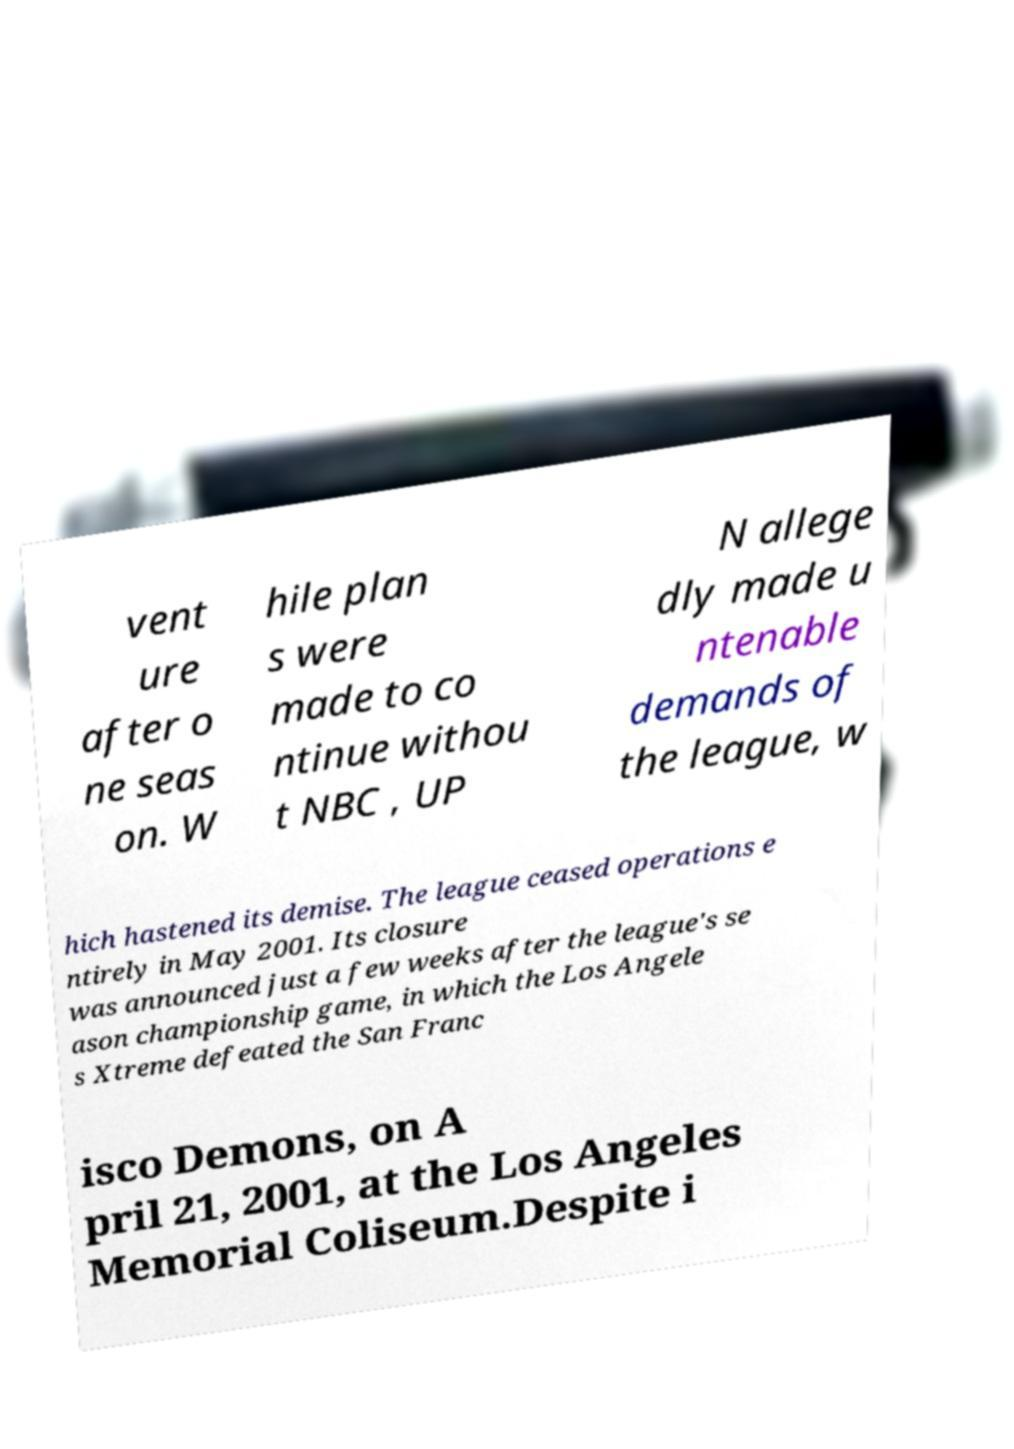Can you read and provide the text displayed in the image?This photo seems to have some interesting text. Can you extract and type it out for me? vent ure after o ne seas on. W hile plan s were made to co ntinue withou t NBC , UP N allege dly made u ntenable demands of the league, w hich hastened its demise. The league ceased operations e ntirely in May 2001. Its closure was announced just a few weeks after the league's se ason championship game, in which the Los Angele s Xtreme defeated the San Franc isco Demons, on A pril 21, 2001, at the Los Angeles Memorial Coliseum.Despite i 